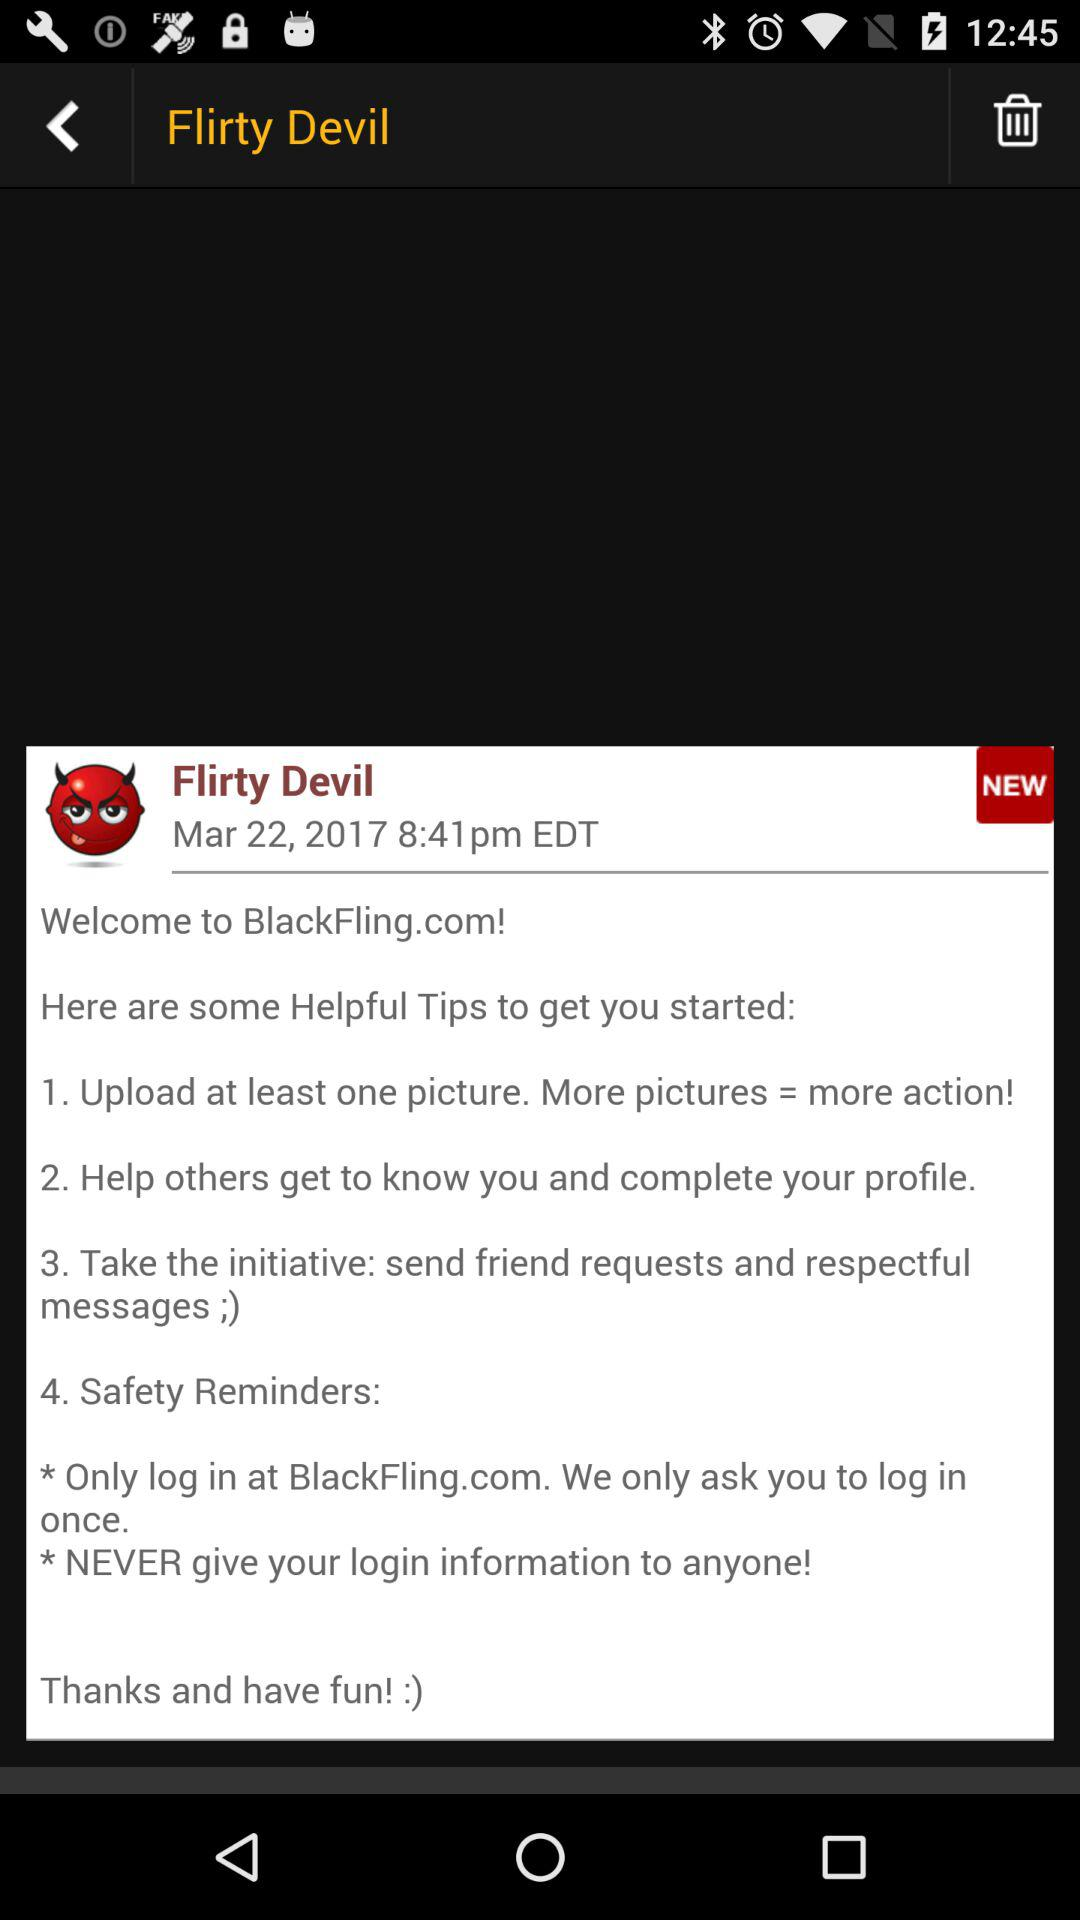How many more helpful tips are there than safety reminders?
Answer the question using a single word or phrase. 2 